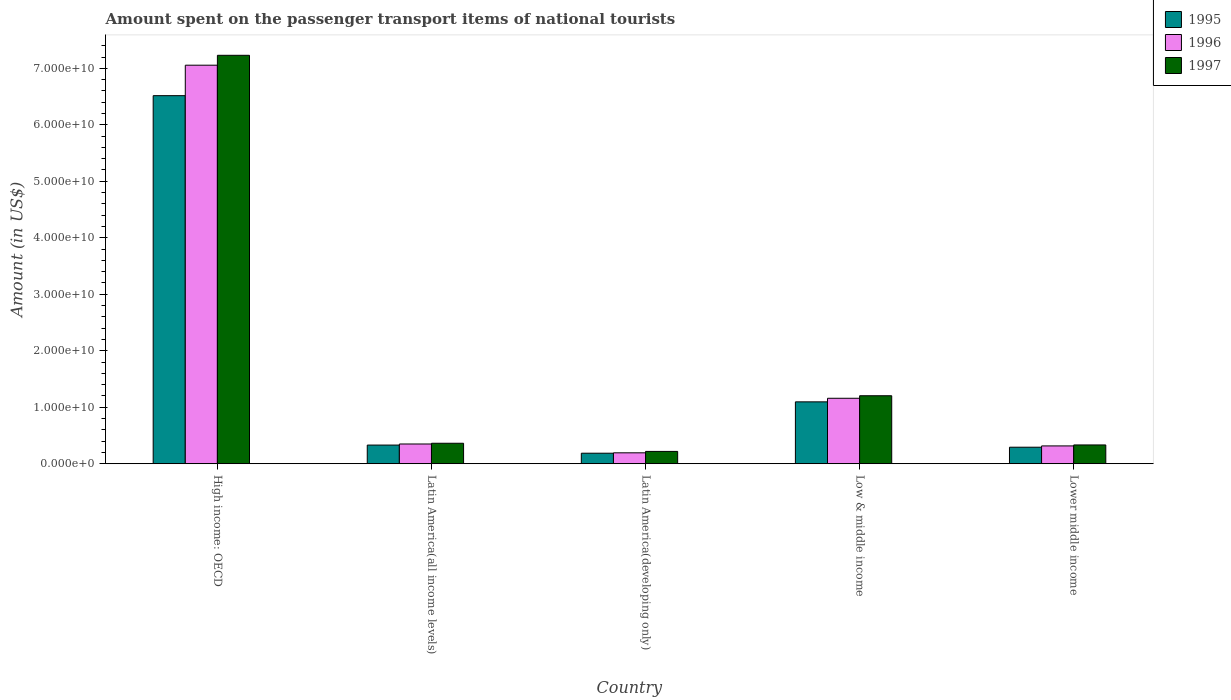How many bars are there on the 1st tick from the left?
Your answer should be compact. 3. How many bars are there on the 3rd tick from the right?
Your response must be concise. 3. What is the label of the 2nd group of bars from the left?
Keep it short and to the point. Latin America(all income levels). What is the amount spent on the passenger transport items of national tourists in 1996 in Latin America(all income levels)?
Offer a very short reply. 3.50e+09. Across all countries, what is the maximum amount spent on the passenger transport items of national tourists in 1995?
Provide a short and direct response. 6.52e+1. Across all countries, what is the minimum amount spent on the passenger transport items of national tourists in 1996?
Your response must be concise. 1.93e+09. In which country was the amount spent on the passenger transport items of national tourists in 1996 maximum?
Keep it short and to the point. High income: OECD. In which country was the amount spent on the passenger transport items of national tourists in 1995 minimum?
Provide a succinct answer. Latin America(developing only). What is the total amount spent on the passenger transport items of national tourists in 1995 in the graph?
Your response must be concise. 8.42e+1. What is the difference between the amount spent on the passenger transport items of national tourists in 1997 in Low & middle income and that in Lower middle income?
Give a very brief answer. 8.71e+09. What is the difference between the amount spent on the passenger transport items of national tourists in 1997 in Low & middle income and the amount spent on the passenger transport items of national tourists in 1995 in Latin America(all income levels)?
Ensure brevity in your answer.  8.73e+09. What is the average amount spent on the passenger transport items of national tourists in 1995 per country?
Ensure brevity in your answer.  1.68e+1. What is the difference between the amount spent on the passenger transport items of national tourists of/in 1997 and amount spent on the passenger transport items of national tourists of/in 1996 in High income: OECD?
Make the answer very short. 1.75e+09. What is the ratio of the amount spent on the passenger transport items of national tourists in 1996 in High income: OECD to that in Latin America(developing only)?
Your response must be concise. 36.51. Is the amount spent on the passenger transport items of national tourists in 1995 in Latin America(all income levels) less than that in Latin America(developing only)?
Make the answer very short. No. Is the difference between the amount spent on the passenger transport items of national tourists in 1997 in High income: OECD and Lower middle income greater than the difference between the amount spent on the passenger transport items of national tourists in 1996 in High income: OECD and Lower middle income?
Your answer should be very brief. Yes. What is the difference between the highest and the second highest amount spent on the passenger transport items of national tourists in 1996?
Make the answer very short. -6.71e+1. What is the difference between the highest and the lowest amount spent on the passenger transport items of national tourists in 1995?
Offer a terse response. 6.33e+1. In how many countries, is the amount spent on the passenger transport items of national tourists in 1995 greater than the average amount spent on the passenger transport items of national tourists in 1995 taken over all countries?
Provide a succinct answer. 1. Is the sum of the amount spent on the passenger transport items of national tourists in 1996 in High income: OECD and Latin America(all income levels) greater than the maximum amount spent on the passenger transport items of national tourists in 1997 across all countries?
Give a very brief answer. Yes. Is it the case that in every country, the sum of the amount spent on the passenger transport items of national tourists in 1996 and amount spent on the passenger transport items of national tourists in 1997 is greater than the amount spent on the passenger transport items of national tourists in 1995?
Your response must be concise. Yes. How many bars are there?
Ensure brevity in your answer.  15. What is the difference between two consecutive major ticks on the Y-axis?
Your answer should be very brief. 1.00e+1. Are the values on the major ticks of Y-axis written in scientific E-notation?
Offer a very short reply. Yes. Does the graph contain any zero values?
Provide a short and direct response. No. Does the graph contain grids?
Your answer should be very brief. No. Where does the legend appear in the graph?
Keep it short and to the point. Top right. How are the legend labels stacked?
Your answer should be compact. Vertical. What is the title of the graph?
Ensure brevity in your answer.  Amount spent on the passenger transport items of national tourists. Does "1984" appear as one of the legend labels in the graph?
Your answer should be compact. No. What is the label or title of the X-axis?
Give a very brief answer. Country. What is the Amount (in US$) in 1995 in High income: OECD?
Provide a succinct answer. 6.52e+1. What is the Amount (in US$) in 1996 in High income: OECD?
Offer a terse response. 7.06e+1. What is the Amount (in US$) in 1997 in High income: OECD?
Your answer should be very brief. 7.23e+1. What is the Amount (in US$) of 1995 in Latin America(all income levels)?
Offer a very short reply. 3.31e+09. What is the Amount (in US$) in 1996 in Latin America(all income levels)?
Give a very brief answer. 3.50e+09. What is the Amount (in US$) in 1997 in Latin America(all income levels)?
Give a very brief answer. 3.63e+09. What is the Amount (in US$) in 1995 in Latin America(developing only)?
Offer a very short reply. 1.86e+09. What is the Amount (in US$) of 1996 in Latin America(developing only)?
Your response must be concise. 1.93e+09. What is the Amount (in US$) in 1997 in Latin America(developing only)?
Offer a very short reply. 2.18e+09. What is the Amount (in US$) in 1995 in Low & middle income?
Keep it short and to the point. 1.10e+1. What is the Amount (in US$) of 1996 in Low & middle income?
Ensure brevity in your answer.  1.16e+1. What is the Amount (in US$) in 1997 in Low & middle income?
Keep it short and to the point. 1.20e+1. What is the Amount (in US$) in 1995 in Lower middle income?
Give a very brief answer. 2.92e+09. What is the Amount (in US$) in 1996 in Lower middle income?
Ensure brevity in your answer.  3.16e+09. What is the Amount (in US$) in 1997 in Lower middle income?
Provide a succinct answer. 3.33e+09. Across all countries, what is the maximum Amount (in US$) in 1995?
Your response must be concise. 6.52e+1. Across all countries, what is the maximum Amount (in US$) of 1996?
Ensure brevity in your answer.  7.06e+1. Across all countries, what is the maximum Amount (in US$) of 1997?
Your answer should be compact. 7.23e+1. Across all countries, what is the minimum Amount (in US$) of 1995?
Give a very brief answer. 1.86e+09. Across all countries, what is the minimum Amount (in US$) of 1996?
Provide a short and direct response. 1.93e+09. Across all countries, what is the minimum Amount (in US$) in 1997?
Offer a very short reply. 2.18e+09. What is the total Amount (in US$) of 1995 in the graph?
Make the answer very short. 8.42e+1. What is the total Amount (in US$) in 1996 in the graph?
Make the answer very short. 9.07e+1. What is the total Amount (in US$) in 1997 in the graph?
Your answer should be very brief. 9.35e+1. What is the difference between the Amount (in US$) of 1995 in High income: OECD and that in Latin America(all income levels)?
Offer a very short reply. 6.19e+1. What is the difference between the Amount (in US$) of 1996 in High income: OECD and that in Latin America(all income levels)?
Offer a very short reply. 6.71e+1. What is the difference between the Amount (in US$) in 1997 in High income: OECD and that in Latin America(all income levels)?
Your response must be concise. 6.87e+1. What is the difference between the Amount (in US$) in 1995 in High income: OECD and that in Latin America(developing only)?
Provide a short and direct response. 6.33e+1. What is the difference between the Amount (in US$) in 1996 in High income: OECD and that in Latin America(developing only)?
Give a very brief answer. 6.86e+1. What is the difference between the Amount (in US$) in 1997 in High income: OECD and that in Latin America(developing only)?
Keep it short and to the point. 7.01e+1. What is the difference between the Amount (in US$) of 1995 in High income: OECD and that in Low & middle income?
Give a very brief answer. 5.42e+1. What is the difference between the Amount (in US$) of 1996 in High income: OECD and that in Low & middle income?
Ensure brevity in your answer.  5.90e+1. What is the difference between the Amount (in US$) in 1997 in High income: OECD and that in Low & middle income?
Give a very brief answer. 6.03e+1. What is the difference between the Amount (in US$) in 1995 in High income: OECD and that in Lower middle income?
Give a very brief answer. 6.22e+1. What is the difference between the Amount (in US$) in 1996 in High income: OECD and that in Lower middle income?
Provide a short and direct response. 6.74e+1. What is the difference between the Amount (in US$) of 1997 in High income: OECD and that in Lower middle income?
Give a very brief answer. 6.90e+1. What is the difference between the Amount (in US$) of 1995 in Latin America(all income levels) and that in Latin America(developing only)?
Ensure brevity in your answer.  1.44e+09. What is the difference between the Amount (in US$) in 1996 in Latin America(all income levels) and that in Latin America(developing only)?
Keep it short and to the point. 1.56e+09. What is the difference between the Amount (in US$) in 1997 in Latin America(all income levels) and that in Latin America(developing only)?
Your answer should be compact. 1.44e+09. What is the difference between the Amount (in US$) in 1995 in Latin America(all income levels) and that in Low & middle income?
Offer a terse response. -7.65e+09. What is the difference between the Amount (in US$) in 1996 in Latin America(all income levels) and that in Low & middle income?
Make the answer very short. -8.09e+09. What is the difference between the Amount (in US$) of 1997 in Latin America(all income levels) and that in Low & middle income?
Keep it short and to the point. -8.41e+09. What is the difference between the Amount (in US$) of 1995 in Latin America(all income levels) and that in Lower middle income?
Make the answer very short. 3.81e+08. What is the difference between the Amount (in US$) of 1996 in Latin America(all income levels) and that in Lower middle income?
Make the answer very short. 3.40e+08. What is the difference between the Amount (in US$) of 1997 in Latin America(all income levels) and that in Lower middle income?
Make the answer very short. 2.98e+08. What is the difference between the Amount (in US$) in 1995 in Latin America(developing only) and that in Low & middle income?
Your response must be concise. -9.09e+09. What is the difference between the Amount (in US$) of 1996 in Latin America(developing only) and that in Low & middle income?
Your response must be concise. -9.65e+09. What is the difference between the Amount (in US$) of 1997 in Latin America(developing only) and that in Low & middle income?
Your response must be concise. -9.85e+09. What is the difference between the Amount (in US$) of 1995 in Latin America(developing only) and that in Lower middle income?
Make the answer very short. -1.06e+09. What is the difference between the Amount (in US$) of 1996 in Latin America(developing only) and that in Lower middle income?
Your answer should be compact. -1.22e+09. What is the difference between the Amount (in US$) of 1997 in Latin America(developing only) and that in Lower middle income?
Offer a terse response. -1.15e+09. What is the difference between the Amount (in US$) of 1995 in Low & middle income and that in Lower middle income?
Your answer should be very brief. 8.03e+09. What is the difference between the Amount (in US$) of 1996 in Low & middle income and that in Lower middle income?
Ensure brevity in your answer.  8.43e+09. What is the difference between the Amount (in US$) in 1997 in Low & middle income and that in Lower middle income?
Make the answer very short. 8.71e+09. What is the difference between the Amount (in US$) of 1995 in High income: OECD and the Amount (in US$) of 1996 in Latin America(all income levels)?
Keep it short and to the point. 6.17e+1. What is the difference between the Amount (in US$) of 1995 in High income: OECD and the Amount (in US$) of 1997 in Latin America(all income levels)?
Your answer should be compact. 6.15e+1. What is the difference between the Amount (in US$) in 1996 in High income: OECD and the Amount (in US$) in 1997 in Latin America(all income levels)?
Your answer should be compact. 6.69e+1. What is the difference between the Amount (in US$) of 1995 in High income: OECD and the Amount (in US$) of 1996 in Latin America(developing only)?
Ensure brevity in your answer.  6.32e+1. What is the difference between the Amount (in US$) in 1995 in High income: OECD and the Amount (in US$) in 1997 in Latin America(developing only)?
Offer a terse response. 6.30e+1. What is the difference between the Amount (in US$) of 1996 in High income: OECD and the Amount (in US$) of 1997 in Latin America(developing only)?
Make the answer very short. 6.84e+1. What is the difference between the Amount (in US$) of 1995 in High income: OECD and the Amount (in US$) of 1996 in Low & middle income?
Your answer should be very brief. 5.36e+1. What is the difference between the Amount (in US$) of 1995 in High income: OECD and the Amount (in US$) of 1997 in Low & middle income?
Make the answer very short. 5.31e+1. What is the difference between the Amount (in US$) in 1996 in High income: OECD and the Amount (in US$) in 1997 in Low & middle income?
Your response must be concise. 5.85e+1. What is the difference between the Amount (in US$) in 1995 in High income: OECD and the Amount (in US$) in 1996 in Lower middle income?
Make the answer very short. 6.20e+1. What is the difference between the Amount (in US$) in 1995 in High income: OECD and the Amount (in US$) in 1997 in Lower middle income?
Provide a short and direct response. 6.18e+1. What is the difference between the Amount (in US$) in 1996 in High income: OECD and the Amount (in US$) in 1997 in Lower middle income?
Provide a short and direct response. 6.72e+1. What is the difference between the Amount (in US$) in 1995 in Latin America(all income levels) and the Amount (in US$) in 1996 in Latin America(developing only)?
Offer a very short reply. 1.37e+09. What is the difference between the Amount (in US$) in 1995 in Latin America(all income levels) and the Amount (in US$) in 1997 in Latin America(developing only)?
Keep it short and to the point. 1.12e+09. What is the difference between the Amount (in US$) in 1996 in Latin America(all income levels) and the Amount (in US$) in 1997 in Latin America(developing only)?
Your answer should be compact. 1.31e+09. What is the difference between the Amount (in US$) in 1995 in Latin America(all income levels) and the Amount (in US$) in 1996 in Low & middle income?
Your response must be concise. -8.28e+09. What is the difference between the Amount (in US$) of 1995 in Latin America(all income levels) and the Amount (in US$) of 1997 in Low & middle income?
Offer a very short reply. -8.73e+09. What is the difference between the Amount (in US$) in 1996 in Latin America(all income levels) and the Amount (in US$) in 1997 in Low & middle income?
Provide a short and direct response. -8.54e+09. What is the difference between the Amount (in US$) in 1995 in Latin America(all income levels) and the Amount (in US$) in 1996 in Lower middle income?
Keep it short and to the point. 1.50e+08. What is the difference between the Amount (in US$) in 1995 in Latin America(all income levels) and the Amount (in US$) in 1997 in Lower middle income?
Offer a very short reply. -2.21e+07. What is the difference between the Amount (in US$) in 1996 in Latin America(all income levels) and the Amount (in US$) in 1997 in Lower middle income?
Offer a very short reply. 1.67e+08. What is the difference between the Amount (in US$) in 1995 in Latin America(developing only) and the Amount (in US$) in 1996 in Low & middle income?
Provide a succinct answer. -9.72e+09. What is the difference between the Amount (in US$) of 1995 in Latin America(developing only) and the Amount (in US$) of 1997 in Low & middle income?
Keep it short and to the point. -1.02e+1. What is the difference between the Amount (in US$) in 1996 in Latin America(developing only) and the Amount (in US$) in 1997 in Low & middle income?
Make the answer very short. -1.01e+1. What is the difference between the Amount (in US$) of 1995 in Latin America(developing only) and the Amount (in US$) of 1996 in Lower middle income?
Provide a succinct answer. -1.29e+09. What is the difference between the Amount (in US$) in 1995 in Latin America(developing only) and the Amount (in US$) in 1997 in Lower middle income?
Ensure brevity in your answer.  -1.46e+09. What is the difference between the Amount (in US$) in 1996 in Latin America(developing only) and the Amount (in US$) in 1997 in Lower middle income?
Provide a succinct answer. -1.40e+09. What is the difference between the Amount (in US$) of 1995 in Low & middle income and the Amount (in US$) of 1996 in Lower middle income?
Offer a terse response. 7.80e+09. What is the difference between the Amount (in US$) of 1995 in Low & middle income and the Amount (in US$) of 1997 in Lower middle income?
Make the answer very short. 7.63e+09. What is the difference between the Amount (in US$) in 1996 in Low & middle income and the Amount (in US$) in 1997 in Lower middle income?
Provide a succinct answer. 8.26e+09. What is the average Amount (in US$) of 1995 per country?
Provide a short and direct response. 1.68e+1. What is the average Amount (in US$) in 1996 per country?
Provide a succinct answer. 1.81e+1. What is the average Amount (in US$) in 1997 per country?
Your answer should be compact. 1.87e+1. What is the difference between the Amount (in US$) in 1995 and Amount (in US$) in 1996 in High income: OECD?
Keep it short and to the point. -5.40e+09. What is the difference between the Amount (in US$) in 1995 and Amount (in US$) in 1997 in High income: OECD?
Your answer should be compact. -7.15e+09. What is the difference between the Amount (in US$) in 1996 and Amount (in US$) in 1997 in High income: OECD?
Give a very brief answer. -1.75e+09. What is the difference between the Amount (in US$) of 1995 and Amount (in US$) of 1996 in Latin America(all income levels)?
Offer a terse response. -1.89e+08. What is the difference between the Amount (in US$) of 1995 and Amount (in US$) of 1997 in Latin America(all income levels)?
Make the answer very short. -3.20e+08. What is the difference between the Amount (in US$) of 1996 and Amount (in US$) of 1997 in Latin America(all income levels)?
Provide a short and direct response. -1.31e+08. What is the difference between the Amount (in US$) in 1995 and Amount (in US$) in 1996 in Latin America(developing only)?
Your answer should be compact. -6.84e+07. What is the difference between the Amount (in US$) of 1995 and Amount (in US$) of 1997 in Latin America(developing only)?
Offer a terse response. -3.19e+08. What is the difference between the Amount (in US$) of 1996 and Amount (in US$) of 1997 in Latin America(developing only)?
Provide a short and direct response. -2.50e+08. What is the difference between the Amount (in US$) of 1995 and Amount (in US$) of 1996 in Low & middle income?
Give a very brief answer. -6.33e+08. What is the difference between the Amount (in US$) in 1995 and Amount (in US$) in 1997 in Low & middle income?
Make the answer very short. -1.08e+09. What is the difference between the Amount (in US$) of 1996 and Amount (in US$) of 1997 in Low & middle income?
Ensure brevity in your answer.  -4.49e+08. What is the difference between the Amount (in US$) of 1995 and Amount (in US$) of 1996 in Lower middle income?
Provide a short and direct response. -2.31e+08. What is the difference between the Amount (in US$) in 1995 and Amount (in US$) in 1997 in Lower middle income?
Provide a short and direct response. -4.03e+08. What is the difference between the Amount (in US$) in 1996 and Amount (in US$) in 1997 in Lower middle income?
Provide a succinct answer. -1.73e+08. What is the ratio of the Amount (in US$) in 1995 in High income: OECD to that in Latin America(all income levels)?
Your answer should be compact. 19.71. What is the ratio of the Amount (in US$) in 1996 in High income: OECD to that in Latin America(all income levels)?
Give a very brief answer. 20.19. What is the ratio of the Amount (in US$) of 1997 in High income: OECD to that in Latin America(all income levels)?
Your answer should be compact. 19.94. What is the ratio of the Amount (in US$) of 1995 in High income: OECD to that in Latin America(developing only)?
Make the answer very short. 34.95. What is the ratio of the Amount (in US$) in 1996 in High income: OECD to that in Latin America(developing only)?
Offer a very short reply. 36.51. What is the ratio of the Amount (in US$) in 1997 in High income: OECD to that in Latin America(developing only)?
Offer a very short reply. 33.12. What is the ratio of the Amount (in US$) of 1995 in High income: OECD to that in Low & middle income?
Make the answer very short. 5.95. What is the ratio of the Amount (in US$) of 1996 in High income: OECD to that in Low & middle income?
Make the answer very short. 6.09. What is the ratio of the Amount (in US$) in 1997 in High income: OECD to that in Low & middle income?
Your response must be concise. 6.01. What is the ratio of the Amount (in US$) in 1995 in High income: OECD to that in Lower middle income?
Keep it short and to the point. 22.28. What is the ratio of the Amount (in US$) in 1996 in High income: OECD to that in Lower middle income?
Offer a terse response. 22.36. What is the ratio of the Amount (in US$) of 1997 in High income: OECD to that in Lower middle income?
Make the answer very short. 21.73. What is the ratio of the Amount (in US$) in 1995 in Latin America(all income levels) to that in Latin America(developing only)?
Ensure brevity in your answer.  1.77. What is the ratio of the Amount (in US$) of 1996 in Latin America(all income levels) to that in Latin America(developing only)?
Keep it short and to the point. 1.81. What is the ratio of the Amount (in US$) of 1997 in Latin America(all income levels) to that in Latin America(developing only)?
Offer a terse response. 1.66. What is the ratio of the Amount (in US$) of 1995 in Latin America(all income levels) to that in Low & middle income?
Your answer should be very brief. 0.3. What is the ratio of the Amount (in US$) in 1996 in Latin America(all income levels) to that in Low & middle income?
Make the answer very short. 0.3. What is the ratio of the Amount (in US$) of 1997 in Latin America(all income levels) to that in Low & middle income?
Ensure brevity in your answer.  0.3. What is the ratio of the Amount (in US$) in 1995 in Latin America(all income levels) to that in Lower middle income?
Give a very brief answer. 1.13. What is the ratio of the Amount (in US$) of 1996 in Latin America(all income levels) to that in Lower middle income?
Provide a short and direct response. 1.11. What is the ratio of the Amount (in US$) of 1997 in Latin America(all income levels) to that in Lower middle income?
Your answer should be compact. 1.09. What is the ratio of the Amount (in US$) in 1995 in Latin America(developing only) to that in Low & middle income?
Keep it short and to the point. 0.17. What is the ratio of the Amount (in US$) in 1996 in Latin America(developing only) to that in Low & middle income?
Your answer should be compact. 0.17. What is the ratio of the Amount (in US$) in 1997 in Latin America(developing only) to that in Low & middle income?
Give a very brief answer. 0.18. What is the ratio of the Amount (in US$) of 1995 in Latin America(developing only) to that in Lower middle income?
Make the answer very short. 0.64. What is the ratio of the Amount (in US$) of 1996 in Latin America(developing only) to that in Lower middle income?
Provide a succinct answer. 0.61. What is the ratio of the Amount (in US$) of 1997 in Latin America(developing only) to that in Lower middle income?
Offer a very short reply. 0.66. What is the ratio of the Amount (in US$) of 1995 in Low & middle income to that in Lower middle income?
Offer a very short reply. 3.75. What is the ratio of the Amount (in US$) of 1996 in Low & middle income to that in Lower middle income?
Make the answer very short. 3.67. What is the ratio of the Amount (in US$) of 1997 in Low & middle income to that in Lower middle income?
Offer a terse response. 3.62. What is the difference between the highest and the second highest Amount (in US$) of 1995?
Give a very brief answer. 5.42e+1. What is the difference between the highest and the second highest Amount (in US$) of 1996?
Provide a short and direct response. 5.90e+1. What is the difference between the highest and the second highest Amount (in US$) in 1997?
Your response must be concise. 6.03e+1. What is the difference between the highest and the lowest Amount (in US$) in 1995?
Offer a very short reply. 6.33e+1. What is the difference between the highest and the lowest Amount (in US$) of 1996?
Ensure brevity in your answer.  6.86e+1. What is the difference between the highest and the lowest Amount (in US$) of 1997?
Ensure brevity in your answer.  7.01e+1. 